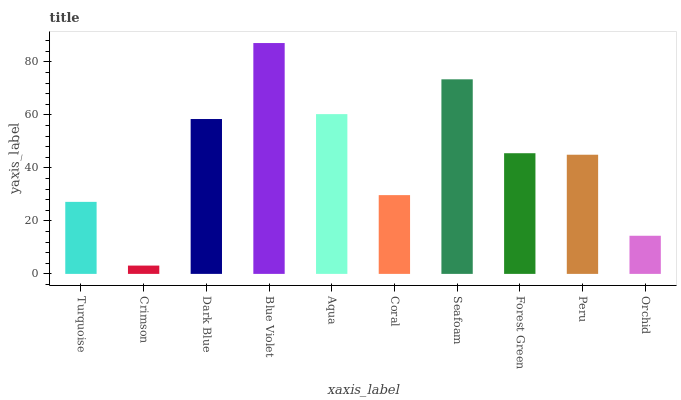Is Crimson the minimum?
Answer yes or no. Yes. Is Blue Violet the maximum?
Answer yes or no. Yes. Is Dark Blue the minimum?
Answer yes or no. No. Is Dark Blue the maximum?
Answer yes or no. No. Is Dark Blue greater than Crimson?
Answer yes or no. Yes. Is Crimson less than Dark Blue?
Answer yes or no. Yes. Is Crimson greater than Dark Blue?
Answer yes or no. No. Is Dark Blue less than Crimson?
Answer yes or no. No. Is Forest Green the high median?
Answer yes or no. Yes. Is Peru the low median?
Answer yes or no. Yes. Is Blue Violet the high median?
Answer yes or no. No. Is Crimson the low median?
Answer yes or no. No. 